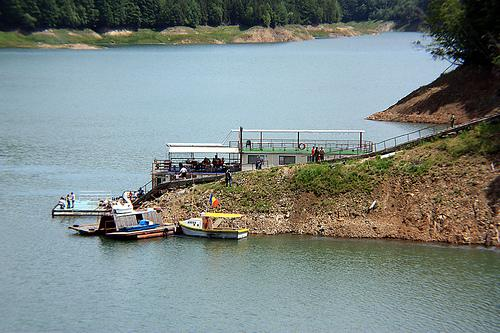People standing on something solid furthest into and above water stand on what?

Choices:
A) plane
B) wharf
C) pier
D) ship pier 